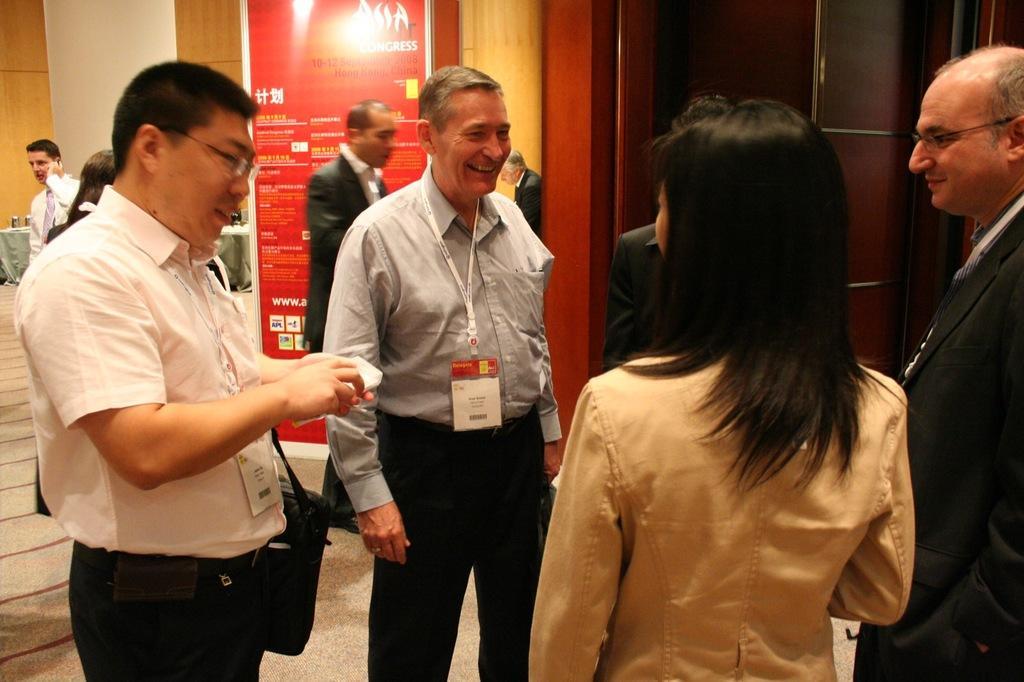Could you give a brief overview of what you see in this image? In this picture there is a group of old men and women, standing and discussing something. Behind there is a red color roller banner and wooden panel wall. On the right side there is a brown wooden door. 